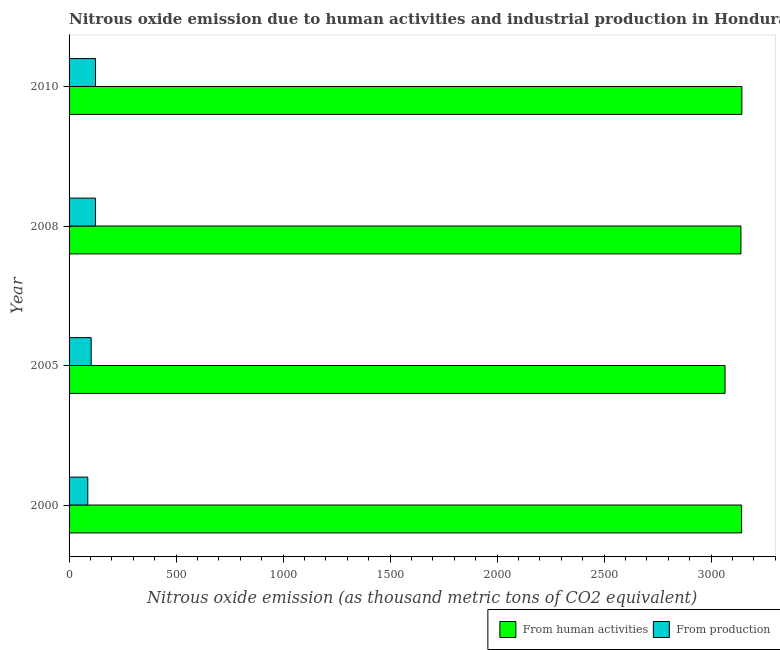How many bars are there on the 1st tick from the top?
Give a very brief answer. 2. In how many cases, is the number of bars for a given year not equal to the number of legend labels?
Keep it short and to the point. 0. What is the amount of emissions from human activities in 2000?
Provide a succinct answer. 3142.2. Across all years, what is the maximum amount of emissions generated from industries?
Your answer should be very brief. 123.5. Across all years, what is the minimum amount of emissions generated from industries?
Offer a terse response. 87.5. What is the total amount of emissions from human activities in the graph?
Make the answer very short. 1.25e+04. What is the difference between the amount of emissions from human activities in 2000 and that in 2005?
Provide a succinct answer. 77.3. What is the difference between the amount of emissions generated from industries in 2000 and the amount of emissions from human activities in 2008?
Keep it short and to the point. -3051.7. What is the average amount of emissions from human activities per year?
Your response must be concise. 3122.43. In the year 2000, what is the difference between the amount of emissions generated from industries and amount of emissions from human activities?
Offer a terse response. -3054.7. What is the ratio of the amount of emissions from human activities in 2000 to that in 2005?
Your answer should be compact. 1.02. Is the amount of emissions from human activities in 2008 less than that in 2010?
Keep it short and to the point. Yes. What is the difference between the highest and the second highest amount of emissions from human activities?
Offer a very short reply. 1.2. In how many years, is the amount of emissions generated from industries greater than the average amount of emissions generated from industries taken over all years?
Your response must be concise. 2. Is the sum of the amount of emissions generated from industries in 2008 and 2010 greater than the maximum amount of emissions from human activities across all years?
Ensure brevity in your answer.  No. What does the 2nd bar from the top in 2000 represents?
Your answer should be very brief. From human activities. What does the 2nd bar from the bottom in 2000 represents?
Offer a terse response. From production. How many bars are there?
Give a very brief answer. 8. How many years are there in the graph?
Ensure brevity in your answer.  4. Does the graph contain any zero values?
Make the answer very short. No. How many legend labels are there?
Keep it short and to the point. 2. How are the legend labels stacked?
Provide a succinct answer. Horizontal. What is the title of the graph?
Your answer should be very brief. Nitrous oxide emission due to human activities and industrial production in Honduras. Does "UN agencies" appear as one of the legend labels in the graph?
Offer a terse response. No. What is the label or title of the X-axis?
Offer a very short reply. Nitrous oxide emission (as thousand metric tons of CO2 equivalent). What is the label or title of the Y-axis?
Ensure brevity in your answer.  Year. What is the Nitrous oxide emission (as thousand metric tons of CO2 equivalent) of From human activities in 2000?
Offer a terse response. 3142.2. What is the Nitrous oxide emission (as thousand metric tons of CO2 equivalent) in From production in 2000?
Give a very brief answer. 87.5. What is the Nitrous oxide emission (as thousand metric tons of CO2 equivalent) in From human activities in 2005?
Your response must be concise. 3064.9. What is the Nitrous oxide emission (as thousand metric tons of CO2 equivalent) of From production in 2005?
Provide a succinct answer. 103.3. What is the Nitrous oxide emission (as thousand metric tons of CO2 equivalent) of From human activities in 2008?
Provide a short and direct response. 3139.2. What is the Nitrous oxide emission (as thousand metric tons of CO2 equivalent) in From production in 2008?
Offer a very short reply. 123.2. What is the Nitrous oxide emission (as thousand metric tons of CO2 equivalent) of From human activities in 2010?
Your answer should be very brief. 3143.4. What is the Nitrous oxide emission (as thousand metric tons of CO2 equivalent) in From production in 2010?
Provide a short and direct response. 123.5. Across all years, what is the maximum Nitrous oxide emission (as thousand metric tons of CO2 equivalent) in From human activities?
Your answer should be compact. 3143.4. Across all years, what is the maximum Nitrous oxide emission (as thousand metric tons of CO2 equivalent) of From production?
Ensure brevity in your answer.  123.5. Across all years, what is the minimum Nitrous oxide emission (as thousand metric tons of CO2 equivalent) in From human activities?
Make the answer very short. 3064.9. Across all years, what is the minimum Nitrous oxide emission (as thousand metric tons of CO2 equivalent) in From production?
Make the answer very short. 87.5. What is the total Nitrous oxide emission (as thousand metric tons of CO2 equivalent) of From human activities in the graph?
Keep it short and to the point. 1.25e+04. What is the total Nitrous oxide emission (as thousand metric tons of CO2 equivalent) in From production in the graph?
Ensure brevity in your answer.  437.5. What is the difference between the Nitrous oxide emission (as thousand metric tons of CO2 equivalent) of From human activities in 2000 and that in 2005?
Offer a terse response. 77.3. What is the difference between the Nitrous oxide emission (as thousand metric tons of CO2 equivalent) in From production in 2000 and that in 2005?
Ensure brevity in your answer.  -15.8. What is the difference between the Nitrous oxide emission (as thousand metric tons of CO2 equivalent) of From human activities in 2000 and that in 2008?
Provide a succinct answer. 3. What is the difference between the Nitrous oxide emission (as thousand metric tons of CO2 equivalent) of From production in 2000 and that in 2008?
Provide a short and direct response. -35.7. What is the difference between the Nitrous oxide emission (as thousand metric tons of CO2 equivalent) of From human activities in 2000 and that in 2010?
Make the answer very short. -1.2. What is the difference between the Nitrous oxide emission (as thousand metric tons of CO2 equivalent) in From production in 2000 and that in 2010?
Your answer should be compact. -36. What is the difference between the Nitrous oxide emission (as thousand metric tons of CO2 equivalent) of From human activities in 2005 and that in 2008?
Give a very brief answer. -74.3. What is the difference between the Nitrous oxide emission (as thousand metric tons of CO2 equivalent) of From production in 2005 and that in 2008?
Provide a succinct answer. -19.9. What is the difference between the Nitrous oxide emission (as thousand metric tons of CO2 equivalent) in From human activities in 2005 and that in 2010?
Offer a very short reply. -78.5. What is the difference between the Nitrous oxide emission (as thousand metric tons of CO2 equivalent) of From production in 2005 and that in 2010?
Provide a short and direct response. -20.2. What is the difference between the Nitrous oxide emission (as thousand metric tons of CO2 equivalent) of From human activities in 2008 and that in 2010?
Offer a terse response. -4.2. What is the difference between the Nitrous oxide emission (as thousand metric tons of CO2 equivalent) in From production in 2008 and that in 2010?
Ensure brevity in your answer.  -0.3. What is the difference between the Nitrous oxide emission (as thousand metric tons of CO2 equivalent) of From human activities in 2000 and the Nitrous oxide emission (as thousand metric tons of CO2 equivalent) of From production in 2005?
Ensure brevity in your answer.  3038.9. What is the difference between the Nitrous oxide emission (as thousand metric tons of CO2 equivalent) in From human activities in 2000 and the Nitrous oxide emission (as thousand metric tons of CO2 equivalent) in From production in 2008?
Offer a very short reply. 3019. What is the difference between the Nitrous oxide emission (as thousand metric tons of CO2 equivalent) in From human activities in 2000 and the Nitrous oxide emission (as thousand metric tons of CO2 equivalent) in From production in 2010?
Provide a succinct answer. 3018.7. What is the difference between the Nitrous oxide emission (as thousand metric tons of CO2 equivalent) in From human activities in 2005 and the Nitrous oxide emission (as thousand metric tons of CO2 equivalent) in From production in 2008?
Offer a very short reply. 2941.7. What is the difference between the Nitrous oxide emission (as thousand metric tons of CO2 equivalent) in From human activities in 2005 and the Nitrous oxide emission (as thousand metric tons of CO2 equivalent) in From production in 2010?
Your answer should be compact. 2941.4. What is the difference between the Nitrous oxide emission (as thousand metric tons of CO2 equivalent) of From human activities in 2008 and the Nitrous oxide emission (as thousand metric tons of CO2 equivalent) of From production in 2010?
Ensure brevity in your answer.  3015.7. What is the average Nitrous oxide emission (as thousand metric tons of CO2 equivalent) of From human activities per year?
Offer a very short reply. 3122.43. What is the average Nitrous oxide emission (as thousand metric tons of CO2 equivalent) in From production per year?
Make the answer very short. 109.38. In the year 2000, what is the difference between the Nitrous oxide emission (as thousand metric tons of CO2 equivalent) in From human activities and Nitrous oxide emission (as thousand metric tons of CO2 equivalent) in From production?
Your answer should be very brief. 3054.7. In the year 2005, what is the difference between the Nitrous oxide emission (as thousand metric tons of CO2 equivalent) of From human activities and Nitrous oxide emission (as thousand metric tons of CO2 equivalent) of From production?
Your answer should be very brief. 2961.6. In the year 2008, what is the difference between the Nitrous oxide emission (as thousand metric tons of CO2 equivalent) in From human activities and Nitrous oxide emission (as thousand metric tons of CO2 equivalent) in From production?
Your answer should be very brief. 3016. In the year 2010, what is the difference between the Nitrous oxide emission (as thousand metric tons of CO2 equivalent) in From human activities and Nitrous oxide emission (as thousand metric tons of CO2 equivalent) in From production?
Offer a terse response. 3019.9. What is the ratio of the Nitrous oxide emission (as thousand metric tons of CO2 equivalent) in From human activities in 2000 to that in 2005?
Provide a short and direct response. 1.03. What is the ratio of the Nitrous oxide emission (as thousand metric tons of CO2 equivalent) in From production in 2000 to that in 2005?
Offer a terse response. 0.85. What is the ratio of the Nitrous oxide emission (as thousand metric tons of CO2 equivalent) of From human activities in 2000 to that in 2008?
Make the answer very short. 1. What is the ratio of the Nitrous oxide emission (as thousand metric tons of CO2 equivalent) in From production in 2000 to that in 2008?
Make the answer very short. 0.71. What is the ratio of the Nitrous oxide emission (as thousand metric tons of CO2 equivalent) in From human activities in 2000 to that in 2010?
Your answer should be very brief. 1. What is the ratio of the Nitrous oxide emission (as thousand metric tons of CO2 equivalent) in From production in 2000 to that in 2010?
Your answer should be very brief. 0.71. What is the ratio of the Nitrous oxide emission (as thousand metric tons of CO2 equivalent) in From human activities in 2005 to that in 2008?
Offer a very short reply. 0.98. What is the ratio of the Nitrous oxide emission (as thousand metric tons of CO2 equivalent) in From production in 2005 to that in 2008?
Offer a very short reply. 0.84. What is the ratio of the Nitrous oxide emission (as thousand metric tons of CO2 equivalent) of From production in 2005 to that in 2010?
Your answer should be compact. 0.84. What is the difference between the highest and the second highest Nitrous oxide emission (as thousand metric tons of CO2 equivalent) of From human activities?
Offer a terse response. 1.2. What is the difference between the highest and the lowest Nitrous oxide emission (as thousand metric tons of CO2 equivalent) in From human activities?
Provide a short and direct response. 78.5. 